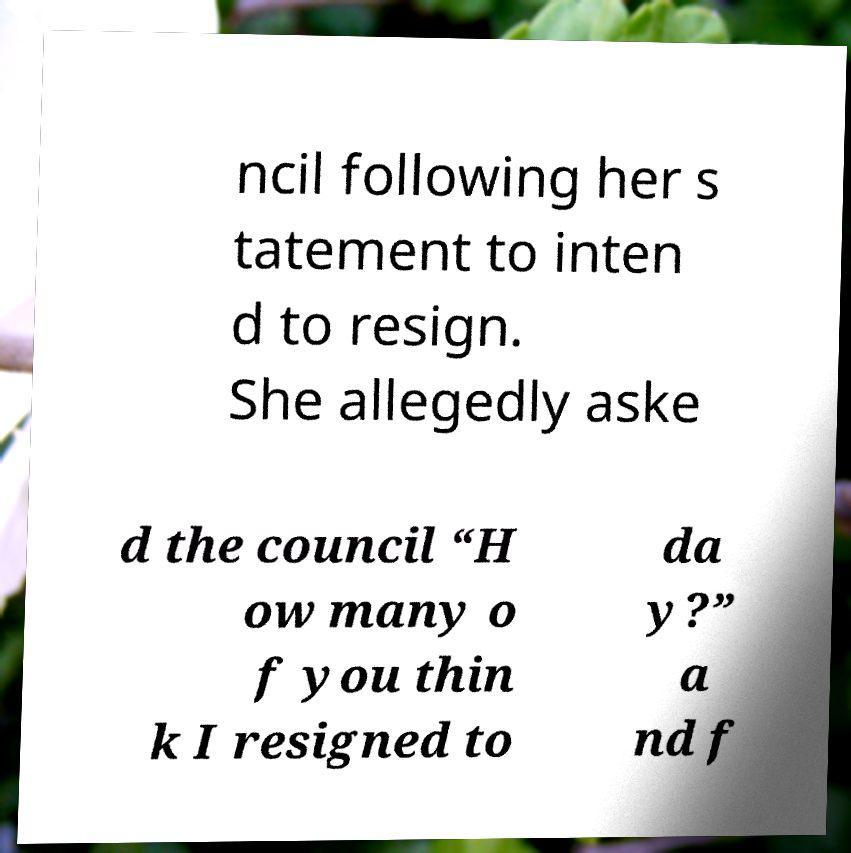Please read and relay the text visible in this image. What does it say? ncil following her s tatement to inten d to resign. She allegedly aske d the council “H ow many o f you thin k I resigned to da y?” a nd f 